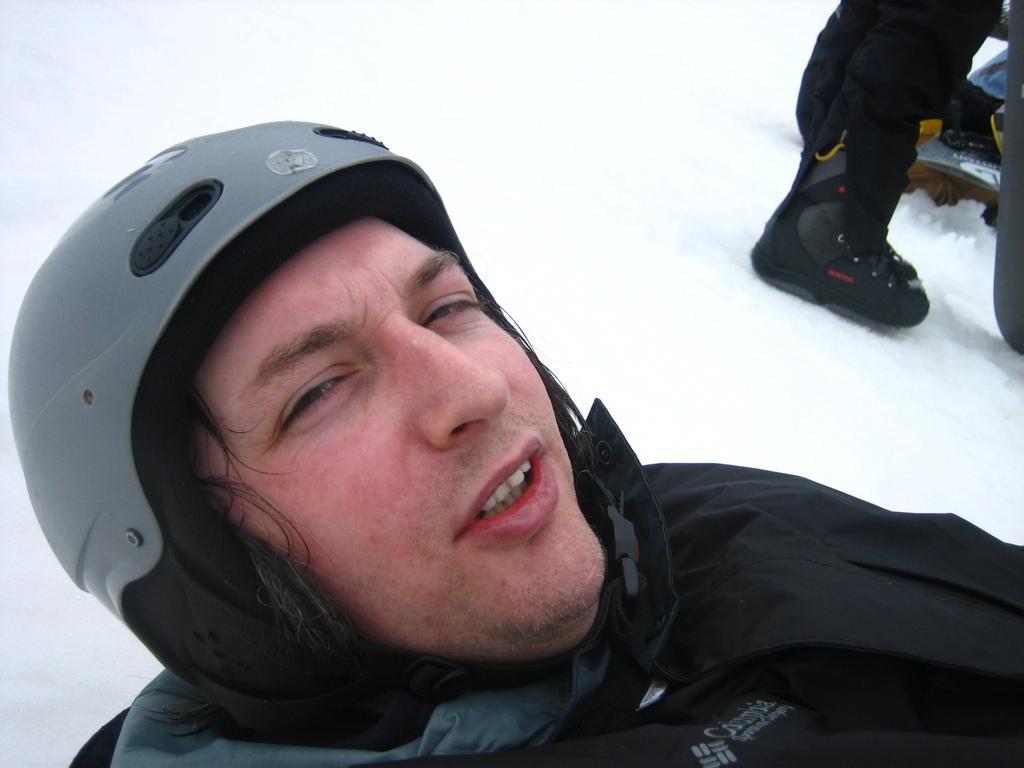How would you summarize this image in a sentence or two? In this picture one man is wearing black coat and helmet and it is taken outside where snow is placed and right corner another man is standing. 